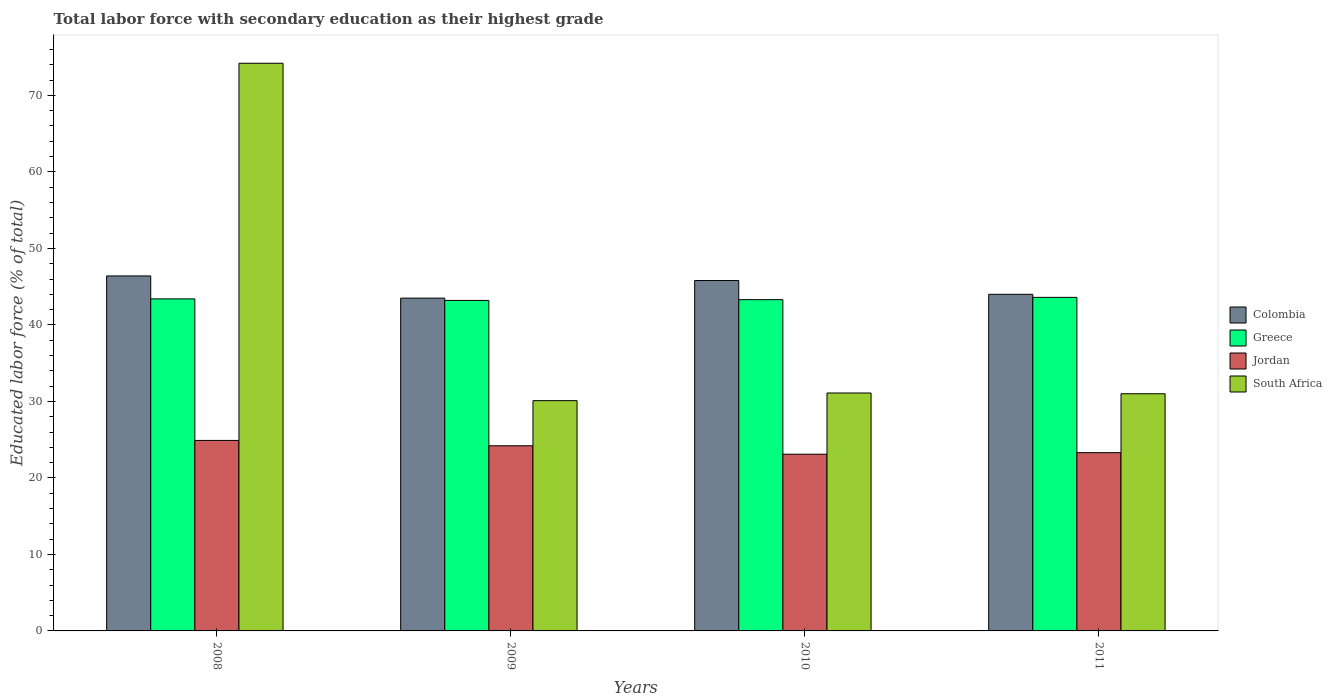How many groups of bars are there?
Make the answer very short. 4. Are the number of bars per tick equal to the number of legend labels?
Provide a succinct answer. Yes. Are the number of bars on each tick of the X-axis equal?
Ensure brevity in your answer.  Yes. How many bars are there on the 3rd tick from the right?
Provide a succinct answer. 4. What is the label of the 4th group of bars from the left?
Ensure brevity in your answer.  2011. What is the percentage of total labor force with primary education in South Africa in 2008?
Offer a very short reply. 74.2. Across all years, what is the maximum percentage of total labor force with primary education in Colombia?
Offer a terse response. 46.4. Across all years, what is the minimum percentage of total labor force with primary education in Colombia?
Offer a terse response. 43.5. What is the total percentage of total labor force with primary education in Colombia in the graph?
Provide a short and direct response. 179.7. What is the difference between the percentage of total labor force with primary education in South Africa in 2008 and that in 2009?
Offer a terse response. 44.1. What is the difference between the percentage of total labor force with primary education in Jordan in 2010 and the percentage of total labor force with primary education in Colombia in 2009?
Make the answer very short. -20.4. What is the average percentage of total labor force with primary education in Jordan per year?
Your answer should be compact. 23.88. In the year 2010, what is the difference between the percentage of total labor force with primary education in Colombia and percentage of total labor force with primary education in Greece?
Give a very brief answer. 2.5. In how many years, is the percentage of total labor force with primary education in Colombia greater than 18 %?
Provide a short and direct response. 4. What is the ratio of the percentage of total labor force with primary education in Jordan in 2008 to that in 2009?
Offer a terse response. 1.03. Is the difference between the percentage of total labor force with primary education in Colombia in 2008 and 2010 greater than the difference between the percentage of total labor force with primary education in Greece in 2008 and 2010?
Provide a short and direct response. Yes. What is the difference between the highest and the second highest percentage of total labor force with primary education in Colombia?
Your answer should be very brief. 0.6. What is the difference between the highest and the lowest percentage of total labor force with primary education in South Africa?
Keep it short and to the point. 44.1. Is the sum of the percentage of total labor force with primary education in Jordan in 2008 and 2010 greater than the maximum percentage of total labor force with primary education in Colombia across all years?
Keep it short and to the point. Yes. Is it the case that in every year, the sum of the percentage of total labor force with primary education in South Africa and percentage of total labor force with primary education in Greece is greater than the sum of percentage of total labor force with primary education in Colombia and percentage of total labor force with primary education in Jordan?
Provide a short and direct response. No. What does the 3rd bar from the left in 2011 represents?
Keep it short and to the point. Jordan. What does the 1st bar from the right in 2009 represents?
Offer a very short reply. South Africa. What is the difference between two consecutive major ticks on the Y-axis?
Keep it short and to the point. 10. Does the graph contain any zero values?
Ensure brevity in your answer.  No. What is the title of the graph?
Make the answer very short. Total labor force with secondary education as their highest grade. What is the label or title of the X-axis?
Offer a terse response. Years. What is the label or title of the Y-axis?
Provide a short and direct response. Educated labor force (% of total). What is the Educated labor force (% of total) in Colombia in 2008?
Offer a very short reply. 46.4. What is the Educated labor force (% of total) in Greece in 2008?
Your answer should be very brief. 43.4. What is the Educated labor force (% of total) of Jordan in 2008?
Provide a short and direct response. 24.9. What is the Educated labor force (% of total) in South Africa in 2008?
Provide a succinct answer. 74.2. What is the Educated labor force (% of total) in Colombia in 2009?
Offer a terse response. 43.5. What is the Educated labor force (% of total) of Greece in 2009?
Your answer should be compact. 43.2. What is the Educated labor force (% of total) in Jordan in 2009?
Provide a succinct answer. 24.2. What is the Educated labor force (% of total) in South Africa in 2009?
Ensure brevity in your answer.  30.1. What is the Educated labor force (% of total) of Colombia in 2010?
Your answer should be compact. 45.8. What is the Educated labor force (% of total) in Greece in 2010?
Your answer should be compact. 43.3. What is the Educated labor force (% of total) of Jordan in 2010?
Offer a very short reply. 23.1. What is the Educated labor force (% of total) of South Africa in 2010?
Ensure brevity in your answer.  31.1. What is the Educated labor force (% of total) in Greece in 2011?
Keep it short and to the point. 43.6. What is the Educated labor force (% of total) in Jordan in 2011?
Your response must be concise. 23.3. What is the Educated labor force (% of total) in South Africa in 2011?
Provide a short and direct response. 31. Across all years, what is the maximum Educated labor force (% of total) in Colombia?
Ensure brevity in your answer.  46.4. Across all years, what is the maximum Educated labor force (% of total) in Greece?
Offer a very short reply. 43.6. Across all years, what is the maximum Educated labor force (% of total) of Jordan?
Offer a very short reply. 24.9. Across all years, what is the maximum Educated labor force (% of total) of South Africa?
Keep it short and to the point. 74.2. Across all years, what is the minimum Educated labor force (% of total) in Colombia?
Provide a short and direct response. 43.5. Across all years, what is the minimum Educated labor force (% of total) in Greece?
Ensure brevity in your answer.  43.2. Across all years, what is the minimum Educated labor force (% of total) in Jordan?
Ensure brevity in your answer.  23.1. Across all years, what is the minimum Educated labor force (% of total) in South Africa?
Offer a terse response. 30.1. What is the total Educated labor force (% of total) in Colombia in the graph?
Keep it short and to the point. 179.7. What is the total Educated labor force (% of total) in Greece in the graph?
Your answer should be very brief. 173.5. What is the total Educated labor force (% of total) of Jordan in the graph?
Your answer should be very brief. 95.5. What is the total Educated labor force (% of total) in South Africa in the graph?
Offer a very short reply. 166.4. What is the difference between the Educated labor force (% of total) in Colombia in 2008 and that in 2009?
Your response must be concise. 2.9. What is the difference between the Educated labor force (% of total) of Greece in 2008 and that in 2009?
Keep it short and to the point. 0.2. What is the difference between the Educated labor force (% of total) in South Africa in 2008 and that in 2009?
Offer a terse response. 44.1. What is the difference between the Educated labor force (% of total) in Colombia in 2008 and that in 2010?
Ensure brevity in your answer.  0.6. What is the difference between the Educated labor force (% of total) of Greece in 2008 and that in 2010?
Provide a succinct answer. 0.1. What is the difference between the Educated labor force (% of total) of Jordan in 2008 and that in 2010?
Ensure brevity in your answer.  1.8. What is the difference between the Educated labor force (% of total) of South Africa in 2008 and that in 2010?
Provide a succinct answer. 43.1. What is the difference between the Educated labor force (% of total) in Colombia in 2008 and that in 2011?
Ensure brevity in your answer.  2.4. What is the difference between the Educated labor force (% of total) in Greece in 2008 and that in 2011?
Your answer should be compact. -0.2. What is the difference between the Educated labor force (% of total) in South Africa in 2008 and that in 2011?
Make the answer very short. 43.2. What is the difference between the Educated labor force (% of total) of Colombia in 2009 and that in 2010?
Offer a very short reply. -2.3. What is the difference between the Educated labor force (% of total) in South Africa in 2009 and that in 2010?
Your answer should be very brief. -1. What is the difference between the Educated labor force (% of total) of Jordan in 2009 and that in 2011?
Your answer should be compact. 0.9. What is the difference between the Educated labor force (% of total) of South Africa in 2009 and that in 2011?
Offer a terse response. -0.9. What is the difference between the Educated labor force (% of total) in Greece in 2010 and that in 2011?
Your answer should be compact. -0.3. What is the difference between the Educated labor force (% of total) in Jordan in 2010 and that in 2011?
Make the answer very short. -0.2. What is the difference between the Educated labor force (% of total) of South Africa in 2010 and that in 2011?
Offer a terse response. 0.1. What is the difference between the Educated labor force (% of total) in Colombia in 2008 and the Educated labor force (% of total) in Greece in 2009?
Give a very brief answer. 3.2. What is the difference between the Educated labor force (% of total) in Colombia in 2008 and the Educated labor force (% of total) in Jordan in 2009?
Make the answer very short. 22.2. What is the difference between the Educated labor force (% of total) of Greece in 2008 and the Educated labor force (% of total) of South Africa in 2009?
Your answer should be very brief. 13.3. What is the difference between the Educated labor force (% of total) of Jordan in 2008 and the Educated labor force (% of total) of South Africa in 2009?
Offer a terse response. -5.2. What is the difference between the Educated labor force (% of total) in Colombia in 2008 and the Educated labor force (% of total) in Greece in 2010?
Provide a short and direct response. 3.1. What is the difference between the Educated labor force (% of total) in Colombia in 2008 and the Educated labor force (% of total) in Jordan in 2010?
Keep it short and to the point. 23.3. What is the difference between the Educated labor force (% of total) of Colombia in 2008 and the Educated labor force (% of total) of South Africa in 2010?
Give a very brief answer. 15.3. What is the difference between the Educated labor force (% of total) in Greece in 2008 and the Educated labor force (% of total) in Jordan in 2010?
Provide a short and direct response. 20.3. What is the difference between the Educated labor force (% of total) of Colombia in 2008 and the Educated labor force (% of total) of Greece in 2011?
Make the answer very short. 2.8. What is the difference between the Educated labor force (% of total) in Colombia in 2008 and the Educated labor force (% of total) in Jordan in 2011?
Your answer should be compact. 23.1. What is the difference between the Educated labor force (% of total) of Greece in 2008 and the Educated labor force (% of total) of Jordan in 2011?
Offer a terse response. 20.1. What is the difference between the Educated labor force (% of total) in Greece in 2008 and the Educated labor force (% of total) in South Africa in 2011?
Give a very brief answer. 12.4. What is the difference between the Educated labor force (% of total) in Colombia in 2009 and the Educated labor force (% of total) in Greece in 2010?
Offer a terse response. 0.2. What is the difference between the Educated labor force (% of total) in Colombia in 2009 and the Educated labor force (% of total) in Jordan in 2010?
Your answer should be compact. 20.4. What is the difference between the Educated labor force (% of total) in Colombia in 2009 and the Educated labor force (% of total) in South Africa in 2010?
Keep it short and to the point. 12.4. What is the difference between the Educated labor force (% of total) in Greece in 2009 and the Educated labor force (% of total) in Jordan in 2010?
Make the answer very short. 20.1. What is the difference between the Educated labor force (% of total) of Colombia in 2009 and the Educated labor force (% of total) of Greece in 2011?
Your answer should be very brief. -0.1. What is the difference between the Educated labor force (% of total) in Colombia in 2009 and the Educated labor force (% of total) in Jordan in 2011?
Provide a short and direct response. 20.2. What is the difference between the Educated labor force (% of total) of Colombia in 2009 and the Educated labor force (% of total) of South Africa in 2011?
Your answer should be very brief. 12.5. What is the difference between the Educated labor force (% of total) of Greece in 2009 and the Educated labor force (% of total) of Jordan in 2011?
Offer a very short reply. 19.9. What is the difference between the Educated labor force (% of total) of Greece in 2010 and the Educated labor force (% of total) of Jordan in 2011?
Keep it short and to the point. 20. What is the difference between the Educated labor force (% of total) in Greece in 2010 and the Educated labor force (% of total) in South Africa in 2011?
Your answer should be very brief. 12.3. What is the average Educated labor force (% of total) of Colombia per year?
Offer a very short reply. 44.92. What is the average Educated labor force (% of total) of Greece per year?
Make the answer very short. 43.38. What is the average Educated labor force (% of total) of Jordan per year?
Offer a terse response. 23.88. What is the average Educated labor force (% of total) of South Africa per year?
Offer a very short reply. 41.6. In the year 2008, what is the difference between the Educated labor force (% of total) in Colombia and Educated labor force (% of total) in South Africa?
Provide a short and direct response. -27.8. In the year 2008, what is the difference between the Educated labor force (% of total) in Greece and Educated labor force (% of total) in Jordan?
Provide a succinct answer. 18.5. In the year 2008, what is the difference between the Educated labor force (% of total) of Greece and Educated labor force (% of total) of South Africa?
Your answer should be compact. -30.8. In the year 2008, what is the difference between the Educated labor force (% of total) of Jordan and Educated labor force (% of total) of South Africa?
Your answer should be very brief. -49.3. In the year 2009, what is the difference between the Educated labor force (% of total) in Colombia and Educated labor force (% of total) in Greece?
Your answer should be compact. 0.3. In the year 2009, what is the difference between the Educated labor force (% of total) in Colombia and Educated labor force (% of total) in Jordan?
Ensure brevity in your answer.  19.3. In the year 2009, what is the difference between the Educated labor force (% of total) in Colombia and Educated labor force (% of total) in South Africa?
Your answer should be compact. 13.4. In the year 2009, what is the difference between the Educated labor force (% of total) in Greece and Educated labor force (% of total) in Jordan?
Ensure brevity in your answer.  19. In the year 2010, what is the difference between the Educated labor force (% of total) of Colombia and Educated labor force (% of total) of Jordan?
Ensure brevity in your answer.  22.7. In the year 2010, what is the difference between the Educated labor force (% of total) of Greece and Educated labor force (% of total) of Jordan?
Provide a short and direct response. 20.2. In the year 2010, what is the difference between the Educated labor force (% of total) in Jordan and Educated labor force (% of total) in South Africa?
Provide a short and direct response. -8. In the year 2011, what is the difference between the Educated labor force (% of total) of Colombia and Educated labor force (% of total) of Greece?
Your answer should be very brief. 0.4. In the year 2011, what is the difference between the Educated labor force (% of total) of Colombia and Educated labor force (% of total) of Jordan?
Your response must be concise. 20.7. In the year 2011, what is the difference between the Educated labor force (% of total) of Greece and Educated labor force (% of total) of Jordan?
Your answer should be compact. 20.3. In the year 2011, what is the difference between the Educated labor force (% of total) in Jordan and Educated labor force (% of total) in South Africa?
Ensure brevity in your answer.  -7.7. What is the ratio of the Educated labor force (% of total) of Colombia in 2008 to that in 2009?
Provide a succinct answer. 1.07. What is the ratio of the Educated labor force (% of total) in Jordan in 2008 to that in 2009?
Provide a short and direct response. 1.03. What is the ratio of the Educated labor force (% of total) in South Africa in 2008 to that in 2009?
Your answer should be very brief. 2.47. What is the ratio of the Educated labor force (% of total) of Colombia in 2008 to that in 2010?
Provide a short and direct response. 1.01. What is the ratio of the Educated labor force (% of total) in Jordan in 2008 to that in 2010?
Offer a terse response. 1.08. What is the ratio of the Educated labor force (% of total) of South Africa in 2008 to that in 2010?
Keep it short and to the point. 2.39. What is the ratio of the Educated labor force (% of total) in Colombia in 2008 to that in 2011?
Provide a short and direct response. 1.05. What is the ratio of the Educated labor force (% of total) of Greece in 2008 to that in 2011?
Your response must be concise. 1. What is the ratio of the Educated labor force (% of total) of Jordan in 2008 to that in 2011?
Offer a terse response. 1.07. What is the ratio of the Educated labor force (% of total) in South Africa in 2008 to that in 2011?
Make the answer very short. 2.39. What is the ratio of the Educated labor force (% of total) of Colombia in 2009 to that in 2010?
Give a very brief answer. 0.95. What is the ratio of the Educated labor force (% of total) of Jordan in 2009 to that in 2010?
Your response must be concise. 1.05. What is the ratio of the Educated labor force (% of total) in South Africa in 2009 to that in 2010?
Provide a succinct answer. 0.97. What is the ratio of the Educated labor force (% of total) of Colombia in 2009 to that in 2011?
Offer a very short reply. 0.99. What is the ratio of the Educated labor force (% of total) in Greece in 2009 to that in 2011?
Your answer should be very brief. 0.99. What is the ratio of the Educated labor force (% of total) of Jordan in 2009 to that in 2011?
Provide a short and direct response. 1.04. What is the ratio of the Educated labor force (% of total) in South Africa in 2009 to that in 2011?
Make the answer very short. 0.97. What is the ratio of the Educated labor force (% of total) of Colombia in 2010 to that in 2011?
Provide a short and direct response. 1.04. What is the ratio of the Educated labor force (% of total) of Jordan in 2010 to that in 2011?
Your answer should be compact. 0.99. What is the ratio of the Educated labor force (% of total) in South Africa in 2010 to that in 2011?
Offer a terse response. 1. What is the difference between the highest and the second highest Educated labor force (% of total) of South Africa?
Ensure brevity in your answer.  43.1. What is the difference between the highest and the lowest Educated labor force (% of total) in Jordan?
Keep it short and to the point. 1.8. What is the difference between the highest and the lowest Educated labor force (% of total) of South Africa?
Your answer should be very brief. 44.1. 